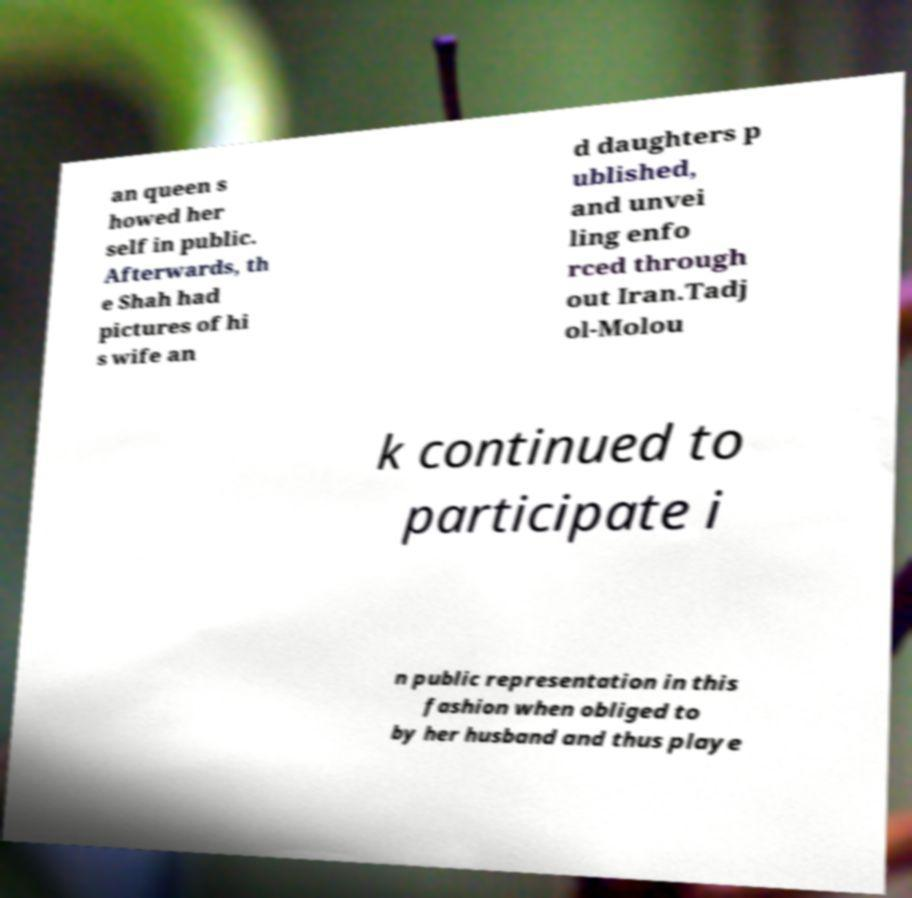Could you assist in decoding the text presented in this image and type it out clearly? an queen s howed her self in public. Afterwards, th e Shah had pictures of hi s wife an d daughters p ublished, and unvei ling enfo rced through out Iran.Tadj ol-Molou k continued to participate i n public representation in this fashion when obliged to by her husband and thus playe 